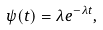<formula> <loc_0><loc_0><loc_500><loc_500>\psi ( t ) = \lambda e ^ { - \lambda t } ,</formula> 